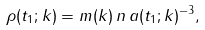Convert formula to latex. <formula><loc_0><loc_0><loc_500><loc_500>\rho ( t _ { 1 } ; k ) = m ( k ) \, n \, a ( t _ { 1 } ; k ) ^ { - 3 } ,</formula> 